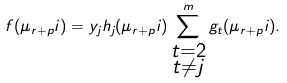<formula> <loc_0><loc_0><loc_500><loc_500>f ( \mu _ { r + p } i ) = y _ { j } h _ { j } ( \mu _ { r + p } i ) \sum _ { \substack { t = 2 \\ t \neq j } } ^ { m } g _ { t } ( \mu _ { r + p } i ) .</formula> 